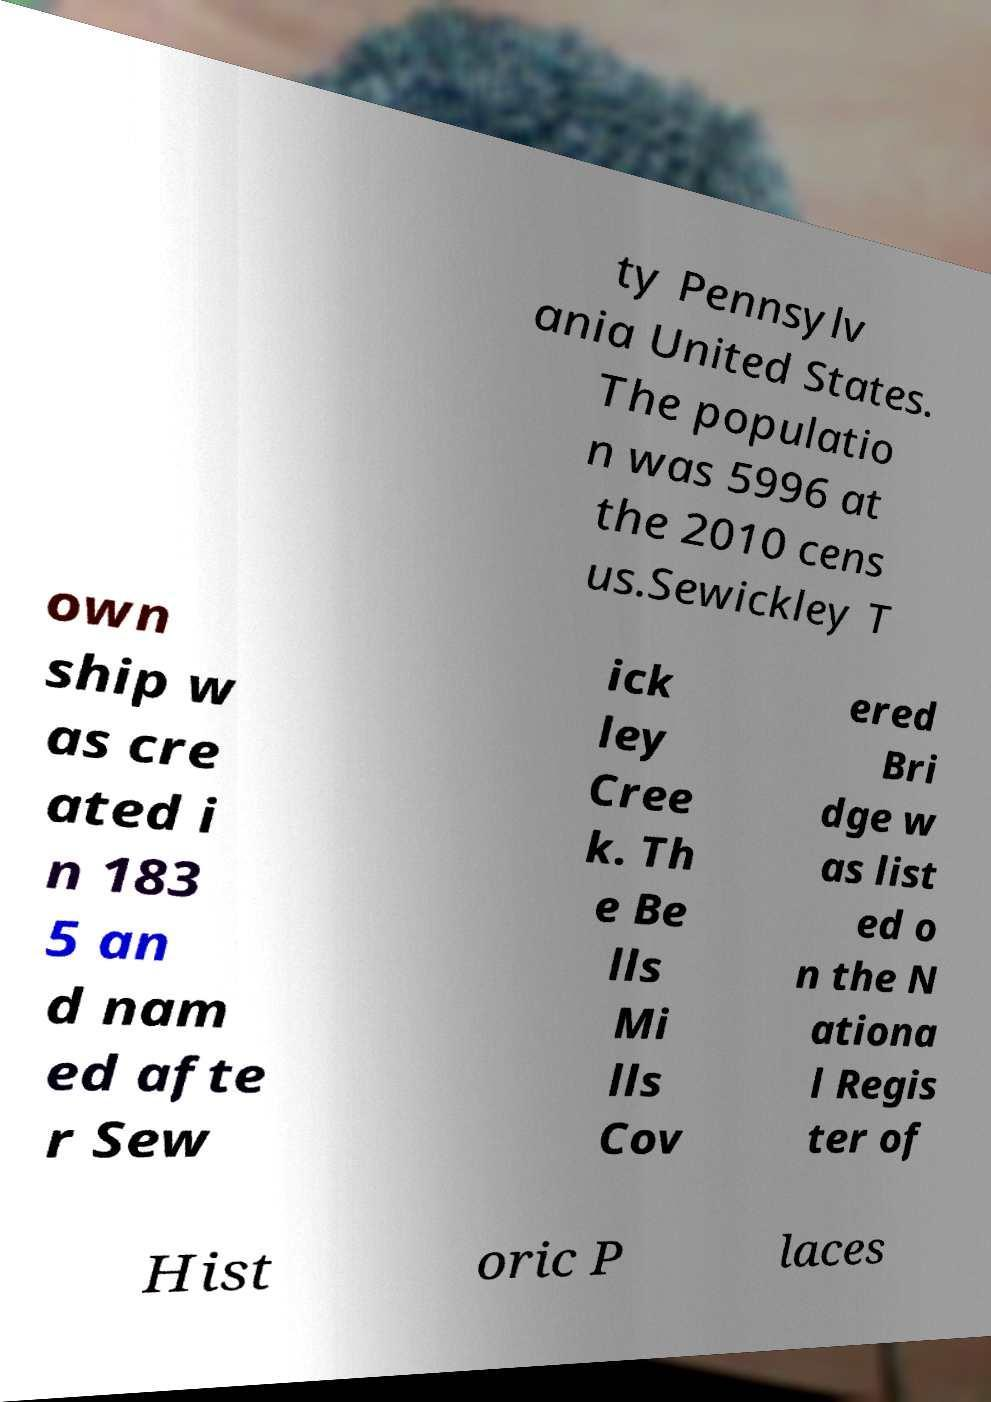There's text embedded in this image that I need extracted. Can you transcribe it verbatim? ty Pennsylv ania United States. The populatio n was 5996 at the 2010 cens us.Sewickley T own ship w as cre ated i n 183 5 an d nam ed afte r Sew ick ley Cree k. Th e Be lls Mi lls Cov ered Bri dge w as list ed o n the N ationa l Regis ter of Hist oric P laces 